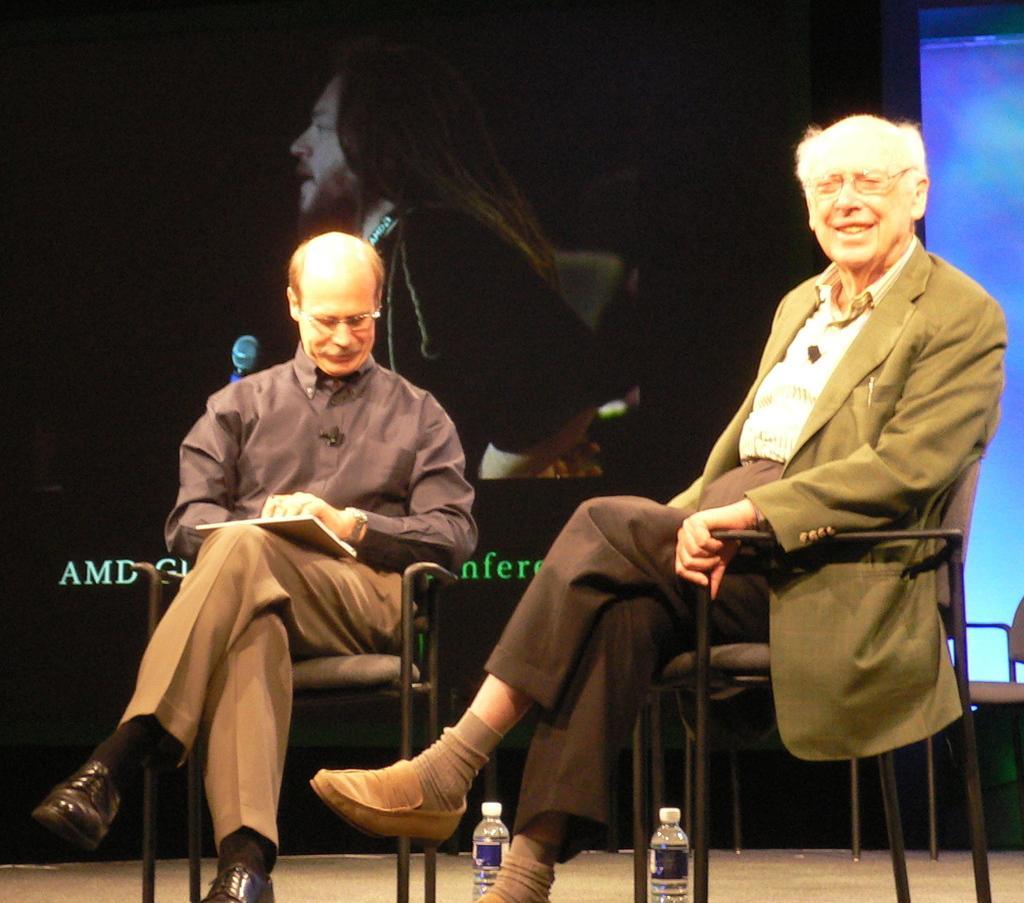Can you describe this image briefly? In this image I can see two people sitting on the chairs. I can see the bottles on the floor. In the background, I can see a picture of a person. 